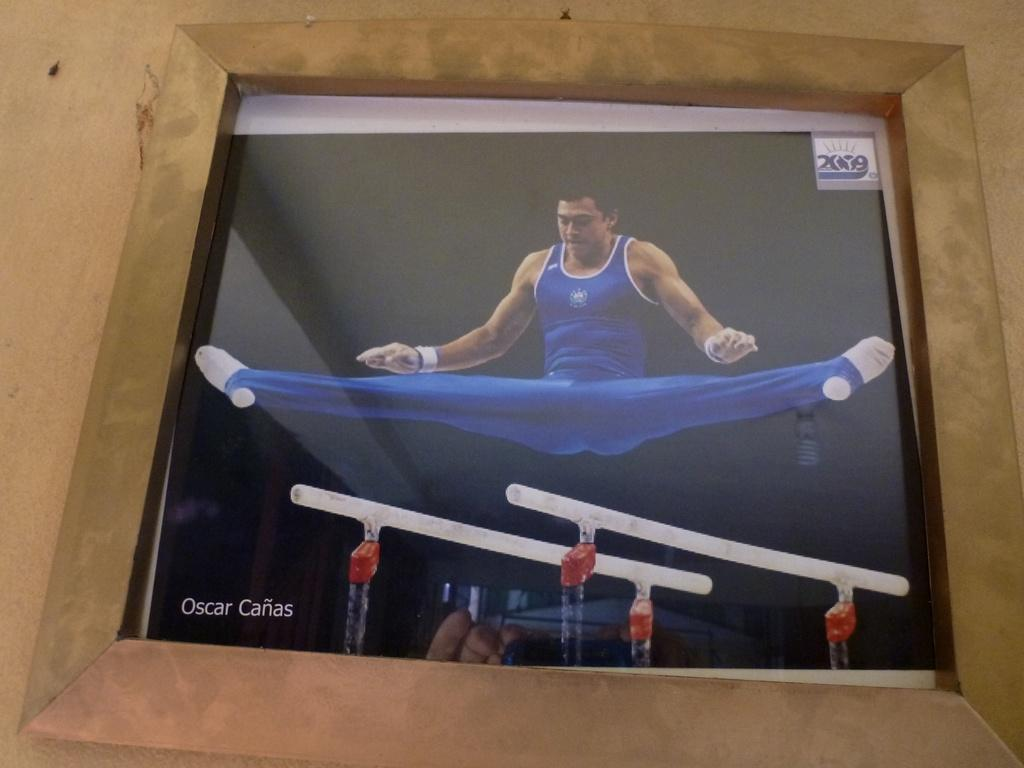<image>
Relay a brief, clear account of the picture shown. Oscar Canas does the splits above the cross bars 